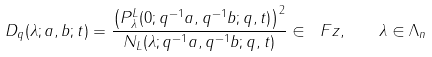<formula> <loc_0><loc_0><loc_500><loc_500>D _ { q } ( \lambda ; a , b ; t ) = \frac { \left ( P _ { \lambda } ^ { L } ( 0 ; q ^ { - 1 } a , q ^ { - 1 } b ; q , t ) \right ) ^ { 2 } } { N _ { L } ( \lambda ; q ^ { - 1 } a , q ^ { - 1 } b ; q , t ) } \in \ F z , \quad \lambda \in \Lambda _ { n }</formula> 